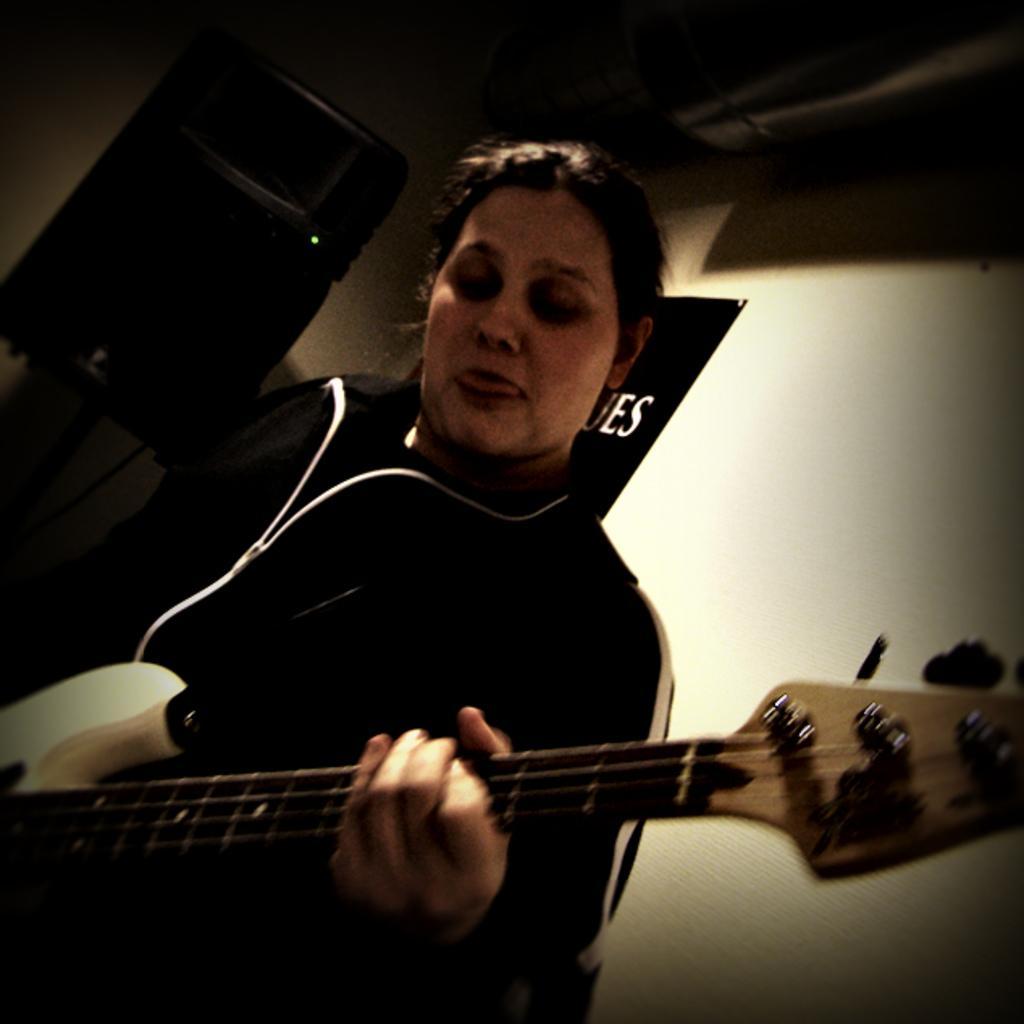Describe this image in one or two sentences. Woman playing guitar and in the background there is white color. 